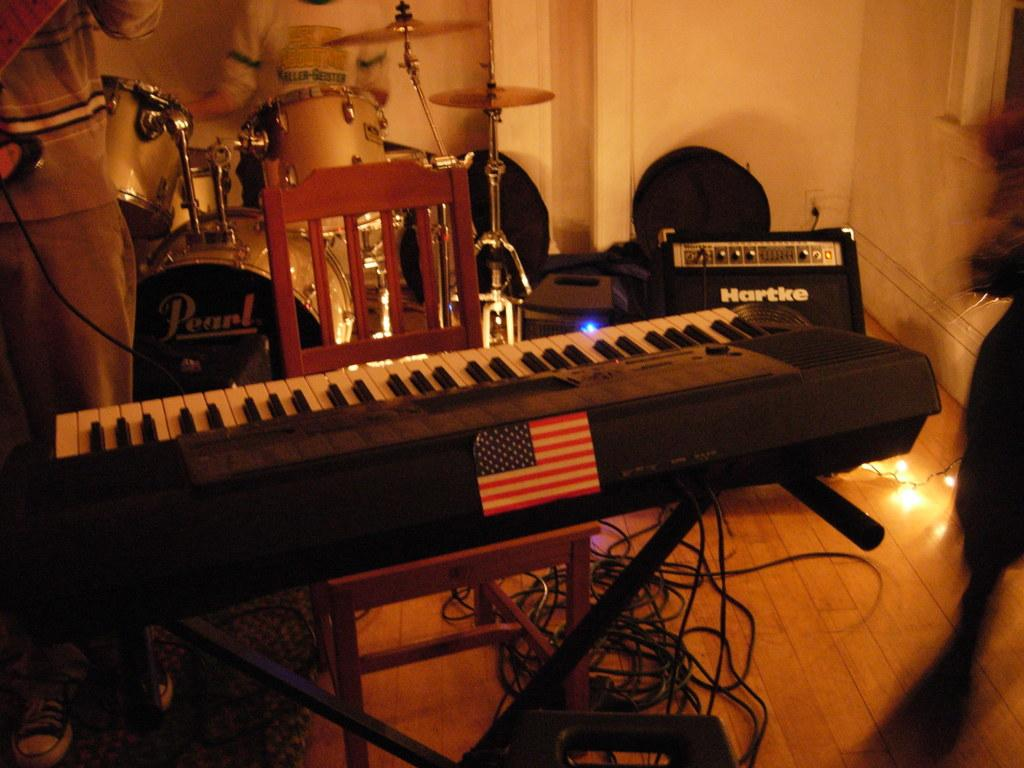What is the main object in the center of the image? There is a keyboard on a chair in the center of the image. Who or what is on the left side of the image? There is a person standing on the left side of the image. What can be seen in the background of the image? There are musical instruments, a wire, a light, and a wall visible in the background. How many cubs are playing with a dime on the keyboard in the image? There are no cubs or dimes present in the image. 